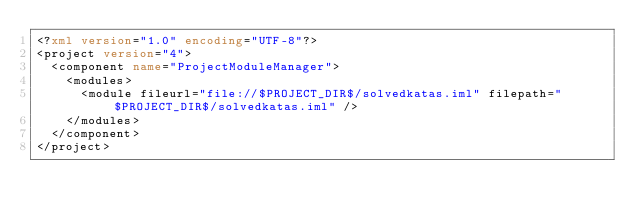Convert code to text. <code><loc_0><loc_0><loc_500><loc_500><_XML_><?xml version="1.0" encoding="UTF-8"?>
<project version="4">
  <component name="ProjectModuleManager">
    <modules>
      <module fileurl="file://$PROJECT_DIR$/solvedkatas.iml" filepath="$PROJECT_DIR$/solvedkatas.iml" />
    </modules>
  </component>
</project></code> 